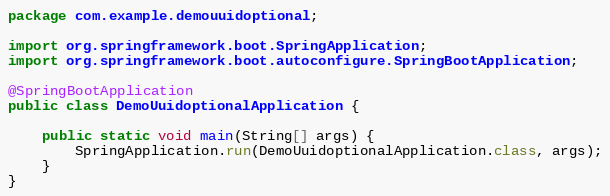Convert code to text. <code><loc_0><loc_0><loc_500><loc_500><_Java_>package com.example.demouuidoptional;

import org.springframework.boot.SpringApplication;
import org.springframework.boot.autoconfigure.SpringBootApplication;

@SpringBootApplication
public class DemoUuidoptionalApplication {

	public static void main(String[] args) {
		SpringApplication.run(DemoUuidoptionalApplication.class, args);
	}
}
</code> 